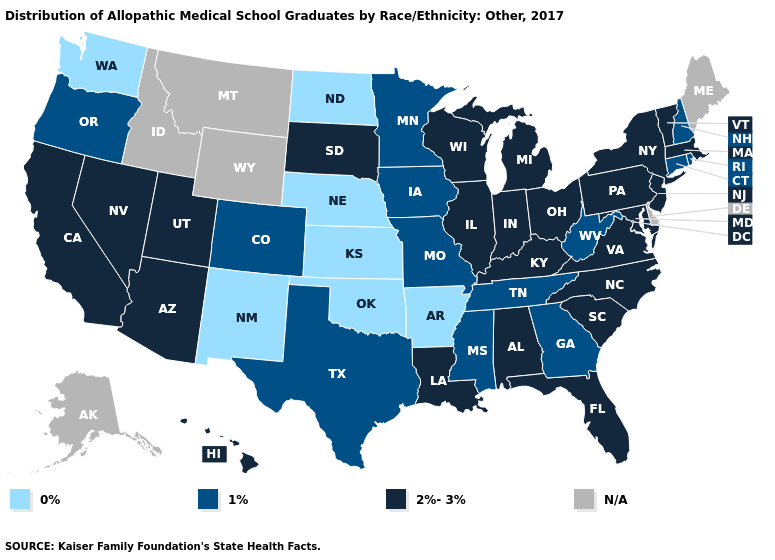What is the value of Wyoming?
Short answer required. N/A. Does Michigan have the highest value in the MidWest?
Write a very short answer. Yes. What is the lowest value in states that border Nebraska?
Be succinct. 0%. Does Ohio have the highest value in the MidWest?
Be succinct. Yes. Does New Hampshire have the lowest value in the Northeast?
Concise answer only. Yes. Does Iowa have the lowest value in the MidWest?
Answer briefly. No. Which states have the highest value in the USA?
Quick response, please. Alabama, Arizona, California, Florida, Hawaii, Illinois, Indiana, Kentucky, Louisiana, Maryland, Massachusetts, Michigan, Nevada, New Jersey, New York, North Carolina, Ohio, Pennsylvania, South Carolina, South Dakota, Utah, Vermont, Virginia, Wisconsin. What is the value of Nebraska?
Short answer required. 0%. What is the value of Hawaii?
Answer briefly. 2%-3%. Name the states that have a value in the range 2%-3%?
Short answer required. Alabama, Arizona, California, Florida, Hawaii, Illinois, Indiana, Kentucky, Louisiana, Maryland, Massachusetts, Michigan, Nevada, New Jersey, New York, North Carolina, Ohio, Pennsylvania, South Carolina, South Dakota, Utah, Vermont, Virginia, Wisconsin. Which states hav the highest value in the Northeast?
Quick response, please. Massachusetts, New Jersey, New York, Pennsylvania, Vermont. Name the states that have a value in the range 0%?
Write a very short answer. Arkansas, Kansas, Nebraska, New Mexico, North Dakota, Oklahoma, Washington. Name the states that have a value in the range 1%?
Write a very short answer. Colorado, Connecticut, Georgia, Iowa, Minnesota, Mississippi, Missouri, New Hampshire, Oregon, Rhode Island, Tennessee, Texas, West Virginia. Is the legend a continuous bar?
Short answer required. No. 